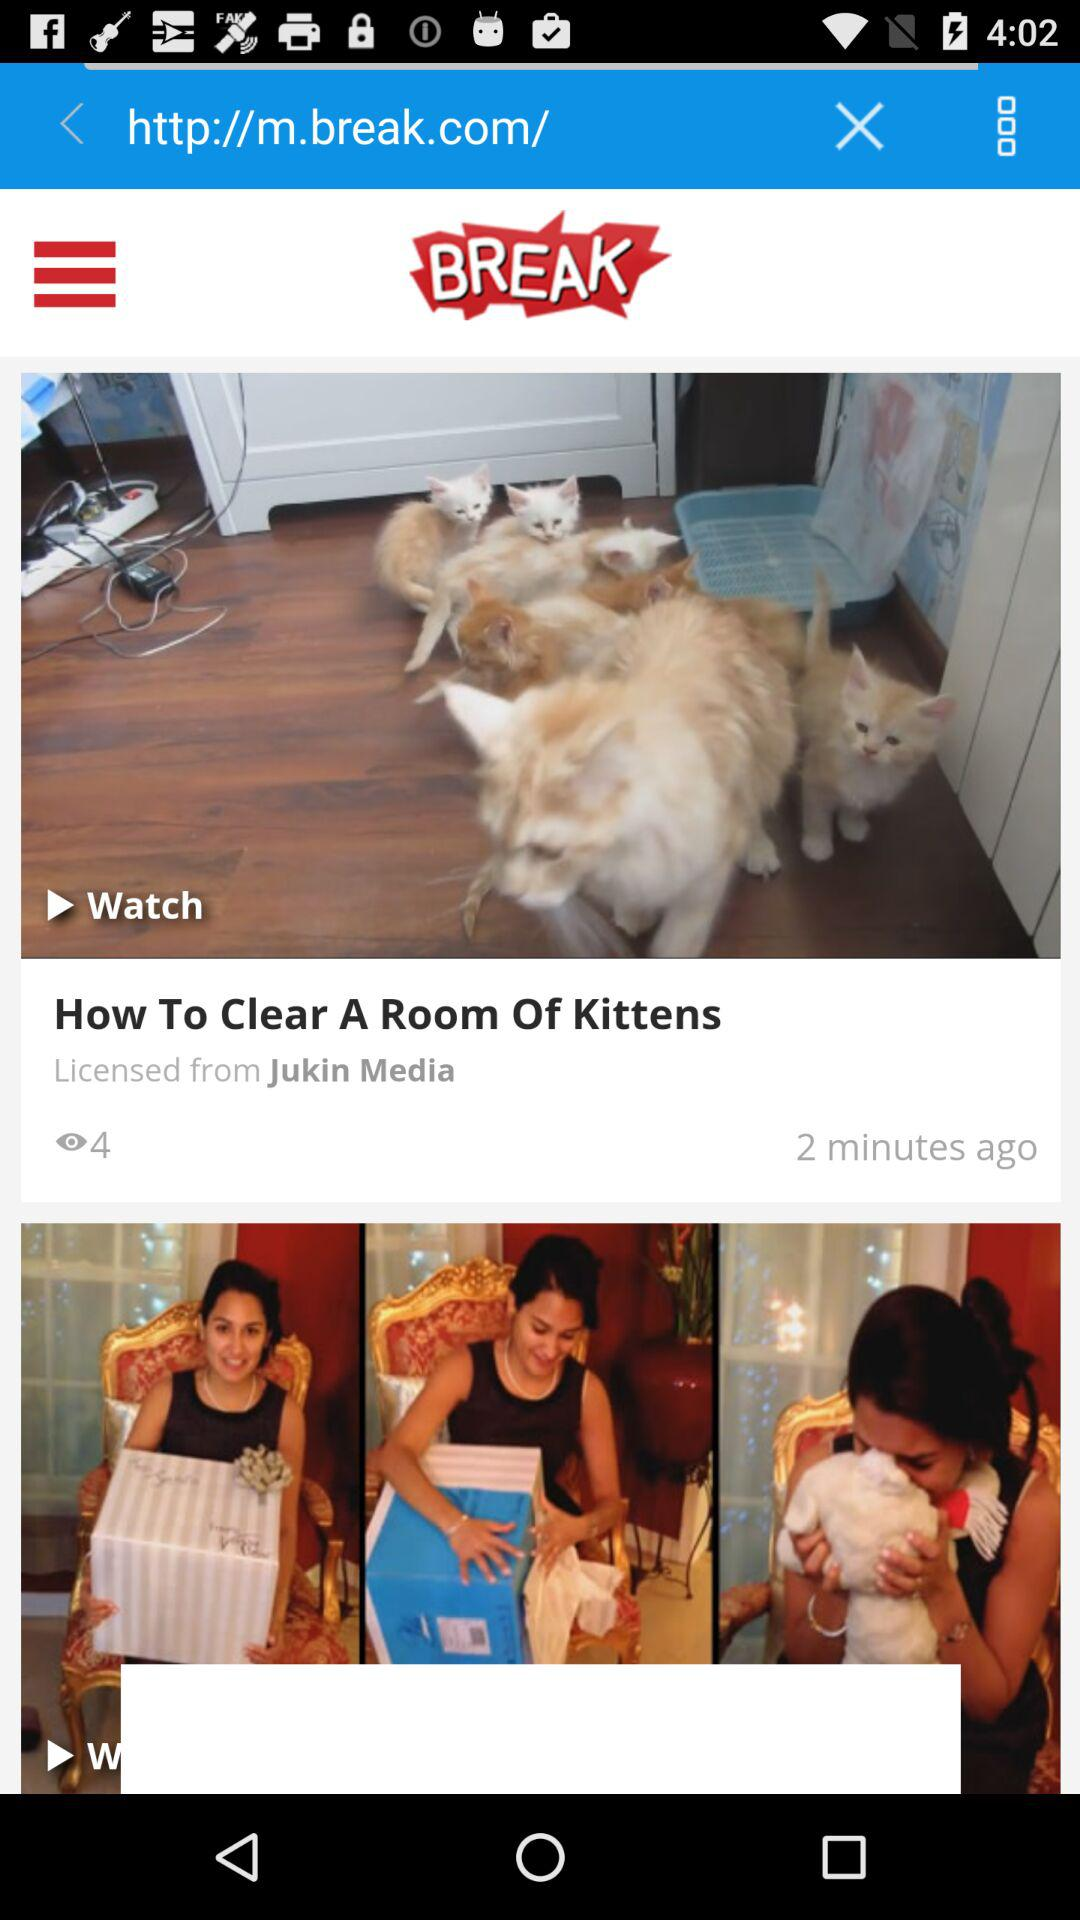When was "How To Clear A Room Of Kittens" uploaded? "How To Clear A Room Of Kittens" was uploaded 2 minutes ago. 